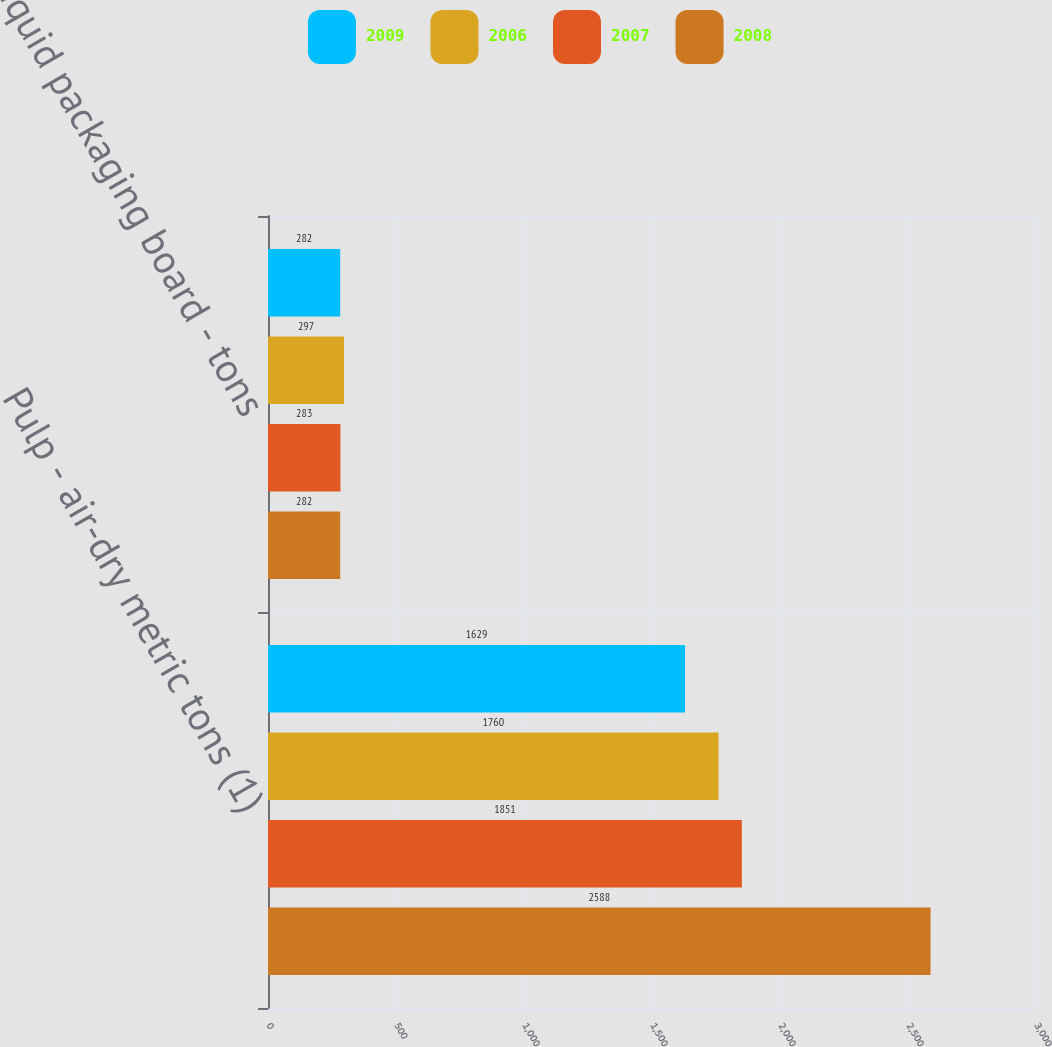<chart> <loc_0><loc_0><loc_500><loc_500><stacked_bar_chart><ecel><fcel>Pulp - air-dry metric tons (1)<fcel>Liquid packaging board - tons<nl><fcel>2009<fcel>1629<fcel>282<nl><fcel>2006<fcel>1760<fcel>297<nl><fcel>2007<fcel>1851<fcel>283<nl><fcel>2008<fcel>2588<fcel>282<nl></chart> 